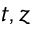<formula> <loc_0><loc_0><loc_500><loc_500>t , z</formula> 